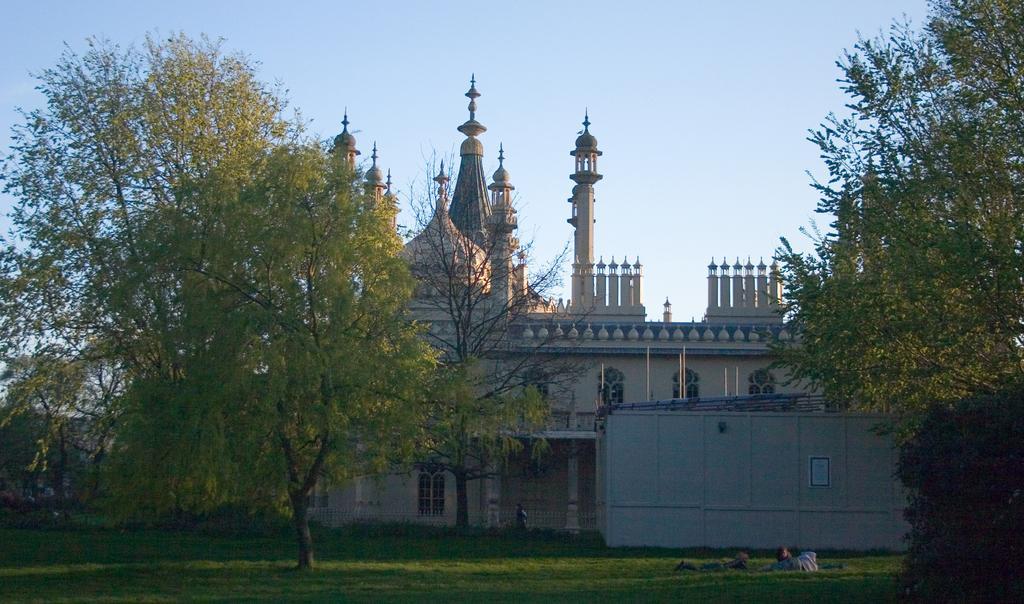In one or two sentences, can you explain what this image depicts? In this picture I can observe building in the middle of the picture. In front of the building there are some trees and grass on the ground. In the background there is sky. 